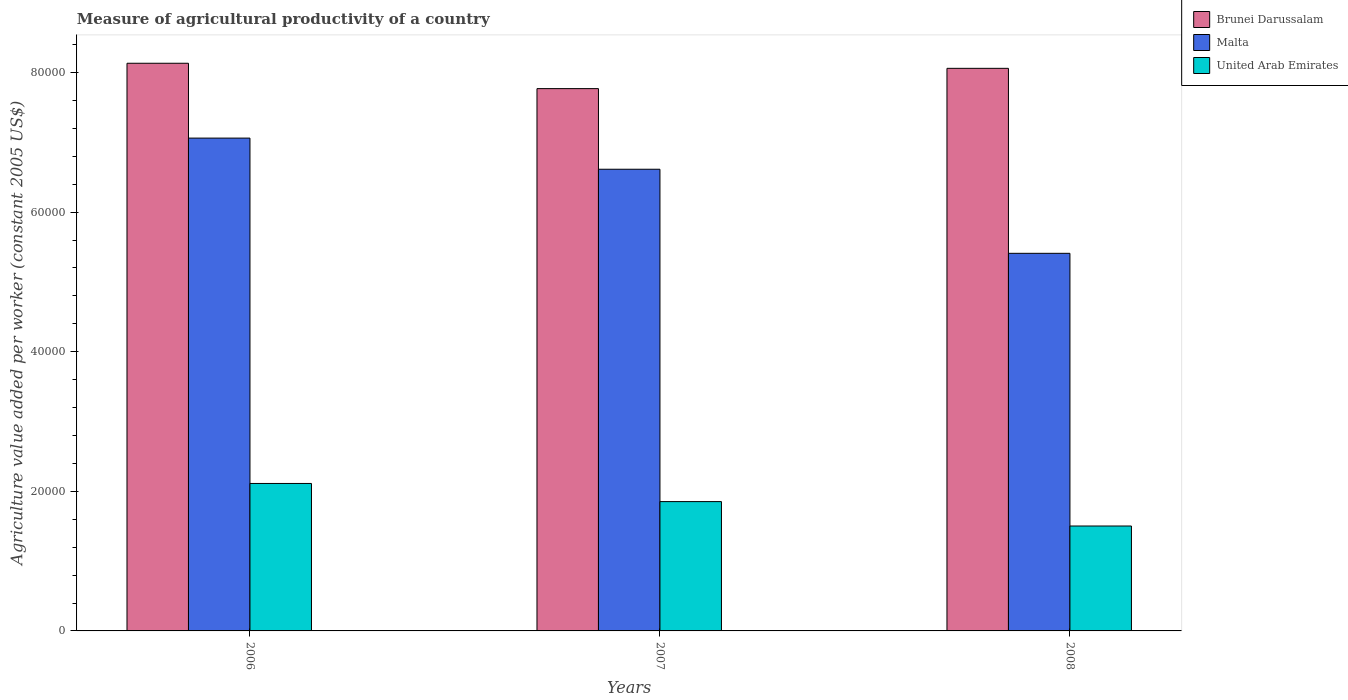Are the number of bars per tick equal to the number of legend labels?
Your answer should be compact. Yes. How many bars are there on the 3rd tick from the right?
Your answer should be compact. 3. What is the measure of agricultural productivity in Malta in 2008?
Offer a terse response. 5.41e+04. Across all years, what is the maximum measure of agricultural productivity in Brunei Darussalam?
Ensure brevity in your answer.  8.13e+04. Across all years, what is the minimum measure of agricultural productivity in Brunei Darussalam?
Provide a short and direct response. 7.77e+04. In which year was the measure of agricultural productivity in Malta minimum?
Your answer should be very brief. 2008. What is the total measure of agricultural productivity in Malta in the graph?
Give a very brief answer. 1.91e+05. What is the difference between the measure of agricultural productivity in Brunei Darussalam in 2006 and that in 2008?
Offer a very short reply. 726.65. What is the difference between the measure of agricultural productivity in Malta in 2008 and the measure of agricultural productivity in Brunei Darussalam in 2007?
Your answer should be very brief. -2.36e+04. What is the average measure of agricultural productivity in Brunei Darussalam per year?
Provide a short and direct response. 7.99e+04. In the year 2007, what is the difference between the measure of agricultural productivity in Malta and measure of agricultural productivity in United Arab Emirates?
Provide a succinct answer. 4.76e+04. What is the ratio of the measure of agricultural productivity in Brunei Darussalam in 2006 to that in 2008?
Your answer should be compact. 1.01. Is the measure of agricultural productivity in Brunei Darussalam in 2007 less than that in 2008?
Provide a succinct answer. Yes. Is the difference between the measure of agricultural productivity in Malta in 2007 and 2008 greater than the difference between the measure of agricultural productivity in United Arab Emirates in 2007 and 2008?
Provide a short and direct response. Yes. What is the difference between the highest and the second highest measure of agricultural productivity in Brunei Darussalam?
Your answer should be compact. 726.65. What is the difference between the highest and the lowest measure of agricultural productivity in Brunei Darussalam?
Your response must be concise. 3633.24. In how many years, is the measure of agricultural productivity in Brunei Darussalam greater than the average measure of agricultural productivity in Brunei Darussalam taken over all years?
Ensure brevity in your answer.  2. Is the sum of the measure of agricultural productivity in United Arab Emirates in 2007 and 2008 greater than the maximum measure of agricultural productivity in Malta across all years?
Offer a terse response. No. What does the 2nd bar from the left in 2007 represents?
Offer a very short reply. Malta. What does the 1st bar from the right in 2006 represents?
Keep it short and to the point. United Arab Emirates. Is it the case that in every year, the sum of the measure of agricultural productivity in Brunei Darussalam and measure of agricultural productivity in United Arab Emirates is greater than the measure of agricultural productivity in Malta?
Make the answer very short. Yes. Are the values on the major ticks of Y-axis written in scientific E-notation?
Provide a succinct answer. No. Does the graph contain any zero values?
Your answer should be very brief. No. Where does the legend appear in the graph?
Provide a short and direct response. Top right. How many legend labels are there?
Keep it short and to the point. 3. What is the title of the graph?
Offer a very short reply. Measure of agricultural productivity of a country. Does "Lesotho" appear as one of the legend labels in the graph?
Your answer should be very brief. No. What is the label or title of the X-axis?
Keep it short and to the point. Years. What is the label or title of the Y-axis?
Provide a short and direct response. Agriculture value added per worker (constant 2005 US$). What is the Agriculture value added per worker (constant 2005 US$) of Brunei Darussalam in 2006?
Your answer should be very brief. 8.13e+04. What is the Agriculture value added per worker (constant 2005 US$) in Malta in 2006?
Offer a very short reply. 7.06e+04. What is the Agriculture value added per worker (constant 2005 US$) in United Arab Emirates in 2006?
Keep it short and to the point. 2.11e+04. What is the Agriculture value added per worker (constant 2005 US$) in Brunei Darussalam in 2007?
Your answer should be very brief. 7.77e+04. What is the Agriculture value added per worker (constant 2005 US$) in Malta in 2007?
Provide a succinct answer. 6.61e+04. What is the Agriculture value added per worker (constant 2005 US$) in United Arab Emirates in 2007?
Your answer should be compact. 1.85e+04. What is the Agriculture value added per worker (constant 2005 US$) in Brunei Darussalam in 2008?
Your answer should be very brief. 8.06e+04. What is the Agriculture value added per worker (constant 2005 US$) in Malta in 2008?
Keep it short and to the point. 5.41e+04. What is the Agriculture value added per worker (constant 2005 US$) of United Arab Emirates in 2008?
Provide a succinct answer. 1.50e+04. Across all years, what is the maximum Agriculture value added per worker (constant 2005 US$) in Brunei Darussalam?
Provide a short and direct response. 8.13e+04. Across all years, what is the maximum Agriculture value added per worker (constant 2005 US$) of Malta?
Keep it short and to the point. 7.06e+04. Across all years, what is the maximum Agriculture value added per worker (constant 2005 US$) of United Arab Emirates?
Make the answer very short. 2.11e+04. Across all years, what is the minimum Agriculture value added per worker (constant 2005 US$) in Brunei Darussalam?
Make the answer very short. 7.77e+04. Across all years, what is the minimum Agriculture value added per worker (constant 2005 US$) of Malta?
Make the answer very short. 5.41e+04. Across all years, what is the minimum Agriculture value added per worker (constant 2005 US$) of United Arab Emirates?
Your answer should be compact. 1.50e+04. What is the total Agriculture value added per worker (constant 2005 US$) of Brunei Darussalam in the graph?
Your answer should be very brief. 2.40e+05. What is the total Agriculture value added per worker (constant 2005 US$) in Malta in the graph?
Your response must be concise. 1.91e+05. What is the total Agriculture value added per worker (constant 2005 US$) of United Arab Emirates in the graph?
Offer a very short reply. 5.47e+04. What is the difference between the Agriculture value added per worker (constant 2005 US$) in Brunei Darussalam in 2006 and that in 2007?
Ensure brevity in your answer.  3633.24. What is the difference between the Agriculture value added per worker (constant 2005 US$) of Malta in 2006 and that in 2007?
Ensure brevity in your answer.  4460.75. What is the difference between the Agriculture value added per worker (constant 2005 US$) of United Arab Emirates in 2006 and that in 2007?
Offer a very short reply. 2599.52. What is the difference between the Agriculture value added per worker (constant 2005 US$) in Brunei Darussalam in 2006 and that in 2008?
Provide a short and direct response. 726.65. What is the difference between the Agriculture value added per worker (constant 2005 US$) of Malta in 2006 and that in 2008?
Your answer should be compact. 1.65e+04. What is the difference between the Agriculture value added per worker (constant 2005 US$) in United Arab Emirates in 2006 and that in 2008?
Your answer should be very brief. 6096.38. What is the difference between the Agriculture value added per worker (constant 2005 US$) in Brunei Darussalam in 2007 and that in 2008?
Provide a short and direct response. -2906.6. What is the difference between the Agriculture value added per worker (constant 2005 US$) in Malta in 2007 and that in 2008?
Make the answer very short. 1.20e+04. What is the difference between the Agriculture value added per worker (constant 2005 US$) of United Arab Emirates in 2007 and that in 2008?
Your answer should be compact. 3496.87. What is the difference between the Agriculture value added per worker (constant 2005 US$) in Brunei Darussalam in 2006 and the Agriculture value added per worker (constant 2005 US$) in Malta in 2007?
Your answer should be compact. 1.52e+04. What is the difference between the Agriculture value added per worker (constant 2005 US$) in Brunei Darussalam in 2006 and the Agriculture value added per worker (constant 2005 US$) in United Arab Emirates in 2007?
Offer a very short reply. 6.28e+04. What is the difference between the Agriculture value added per worker (constant 2005 US$) in Malta in 2006 and the Agriculture value added per worker (constant 2005 US$) in United Arab Emirates in 2007?
Make the answer very short. 5.21e+04. What is the difference between the Agriculture value added per worker (constant 2005 US$) of Brunei Darussalam in 2006 and the Agriculture value added per worker (constant 2005 US$) of Malta in 2008?
Your answer should be compact. 2.72e+04. What is the difference between the Agriculture value added per worker (constant 2005 US$) of Brunei Darussalam in 2006 and the Agriculture value added per worker (constant 2005 US$) of United Arab Emirates in 2008?
Make the answer very short. 6.63e+04. What is the difference between the Agriculture value added per worker (constant 2005 US$) of Malta in 2006 and the Agriculture value added per worker (constant 2005 US$) of United Arab Emirates in 2008?
Make the answer very short. 5.56e+04. What is the difference between the Agriculture value added per worker (constant 2005 US$) of Brunei Darussalam in 2007 and the Agriculture value added per worker (constant 2005 US$) of Malta in 2008?
Provide a short and direct response. 2.36e+04. What is the difference between the Agriculture value added per worker (constant 2005 US$) in Brunei Darussalam in 2007 and the Agriculture value added per worker (constant 2005 US$) in United Arab Emirates in 2008?
Your answer should be very brief. 6.27e+04. What is the difference between the Agriculture value added per worker (constant 2005 US$) of Malta in 2007 and the Agriculture value added per worker (constant 2005 US$) of United Arab Emirates in 2008?
Ensure brevity in your answer.  5.11e+04. What is the average Agriculture value added per worker (constant 2005 US$) in Brunei Darussalam per year?
Keep it short and to the point. 7.99e+04. What is the average Agriculture value added per worker (constant 2005 US$) in Malta per year?
Provide a succinct answer. 6.36e+04. What is the average Agriculture value added per worker (constant 2005 US$) in United Arab Emirates per year?
Provide a short and direct response. 1.82e+04. In the year 2006, what is the difference between the Agriculture value added per worker (constant 2005 US$) of Brunei Darussalam and Agriculture value added per worker (constant 2005 US$) of Malta?
Your response must be concise. 1.07e+04. In the year 2006, what is the difference between the Agriculture value added per worker (constant 2005 US$) in Brunei Darussalam and Agriculture value added per worker (constant 2005 US$) in United Arab Emirates?
Provide a short and direct response. 6.02e+04. In the year 2006, what is the difference between the Agriculture value added per worker (constant 2005 US$) in Malta and Agriculture value added per worker (constant 2005 US$) in United Arab Emirates?
Make the answer very short. 4.95e+04. In the year 2007, what is the difference between the Agriculture value added per worker (constant 2005 US$) of Brunei Darussalam and Agriculture value added per worker (constant 2005 US$) of Malta?
Ensure brevity in your answer.  1.16e+04. In the year 2007, what is the difference between the Agriculture value added per worker (constant 2005 US$) of Brunei Darussalam and Agriculture value added per worker (constant 2005 US$) of United Arab Emirates?
Offer a terse response. 5.92e+04. In the year 2007, what is the difference between the Agriculture value added per worker (constant 2005 US$) in Malta and Agriculture value added per worker (constant 2005 US$) in United Arab Emirates?
Keep it short and to the point. 4.76e+04. In the year 2008, what is the difference between the Agriculture value added per worker (constant 2005 US$) of Brunei Darussalam and Agriculture value added per worker (constant 2005 US$) of Malta?
Make the answer very short. 2.65e+04. In the year 2008, what is the difference between the Agriculture value added per worker (constant 2005 US$) in Brunei Darussalam and Agriculture value added per worker (constant 2005 US$) in United Arab Emirates?
Give a very brief answer. 6.56e+04. In the year 2008, what is the difference between the Agriculture value added per worker (constant 2005 US$) of Malta and Agriculture value added per worker (constant 2005 US$) of United Arab Emirates?
Provide a short and direct response. 3.91e+04. What is the ratio of the Agriculture value added per worker (constant 2005 US$) of Brunei Darussalam in 2006 to that in 2007?
Provide a short and direct response. 1.05. What is the ratio of the Agriculture value added per worker (constant 2005 US$) in Malta in 2006 to that in 2007?
Give a very brief answer. 1.07. What is the ratio of the Agriculture value added per worker (constant 2005 US$) in United Arab Emirates in 2006 to that in 2007?
Your response must be concise. 1.14. What is the ratio of the Agriculture value added per worker (constant 2005 US$) in Malta in 2006 to that in 2008?
Give a very brief answer. 1.31. What is the ratio of the Agriculture value added per worker (constant 2005 US$) in United Arab Emirates in 2006 to that in 2008?
Give a very brief answer. 1.41. What is the ratio of the Agriculture value added per worker (constant 2005 US$) of Brunei Darussalam in 2007 to that in 2008?
Ensure brevity in your answer.  0.96. What is the ratio of the Agriculture value added per worker (constant 2005 US$) in Malta in 2007 to that in 2008?
Provide a short and direct response. 1.22. What is the ratio of the Agriculture value added per worker (constant 2005 US$) of United Arab Emirates in 2007 to that in 2008?
Offer a terse response. 1.23. What is the difference between the highest and the second highest Agriculture value added per worker (constant 2005 US$) in Brunei Darussalam?
Make the answer very short. 726.65. What is the difference between the highest and the second highest Agriculture value added per worker (constant 2005 US$) of Malta?
Provide a short and direct response. 4460.75. What is the difference between the highest and the second highest Agriculture value added per worker (constant 2005 US$) in United Arab Emirates?
Your response must be concise. 2599.52. What is the difference between the highest and the lowest Agriculture value added per worker (constant 2005 US$) of Brunei Darussalam?
Offer a terse response. 3633.24. What is the difference between the highest and the lowest Agriculture value added per worker (constant 2005 US$) of Malta?
Your answer should be compact. 1.65e+04. What is the difference between the highest and the lowest Agriculture value added per worker (constant 2005 US$) of United Arab Emirates?
Offer a terse response. 6096.38. 